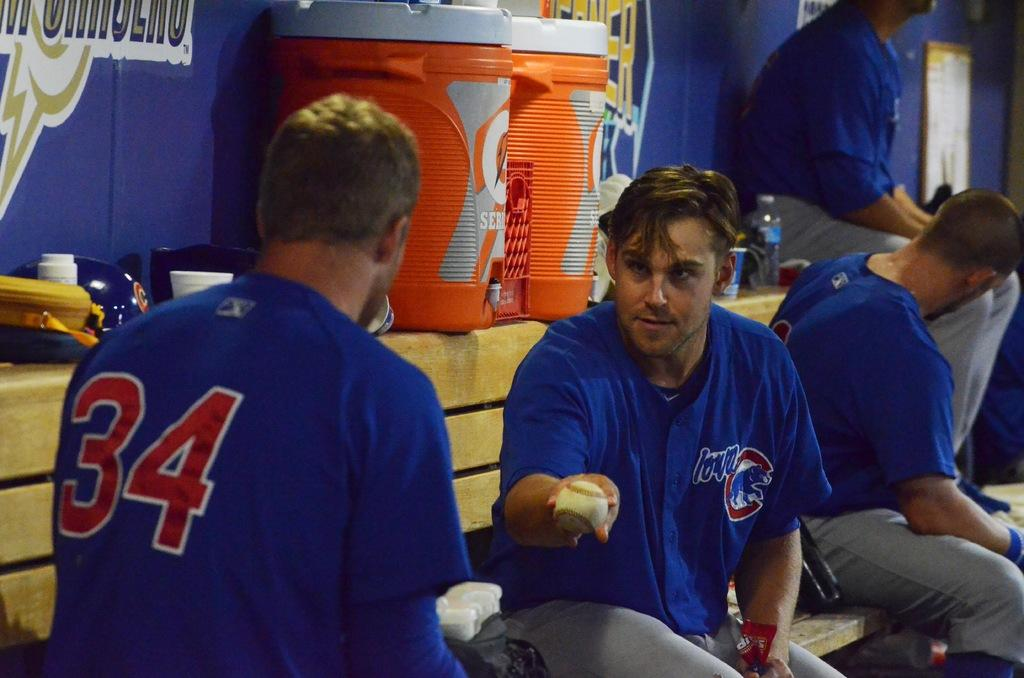<image>
Write a terse but informative summary of the picture. a player wearing thirty four interacting in the dugout 